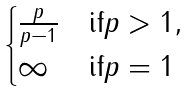Convert formula to latex. <formula><loc_0><loc_0><loc_500><loc_500>\begin{cases} \frac { p } { p - 1 } & \text {if} p > 1 , \\ \infty & \text {if} p = 1 \end{cases}</formula> 